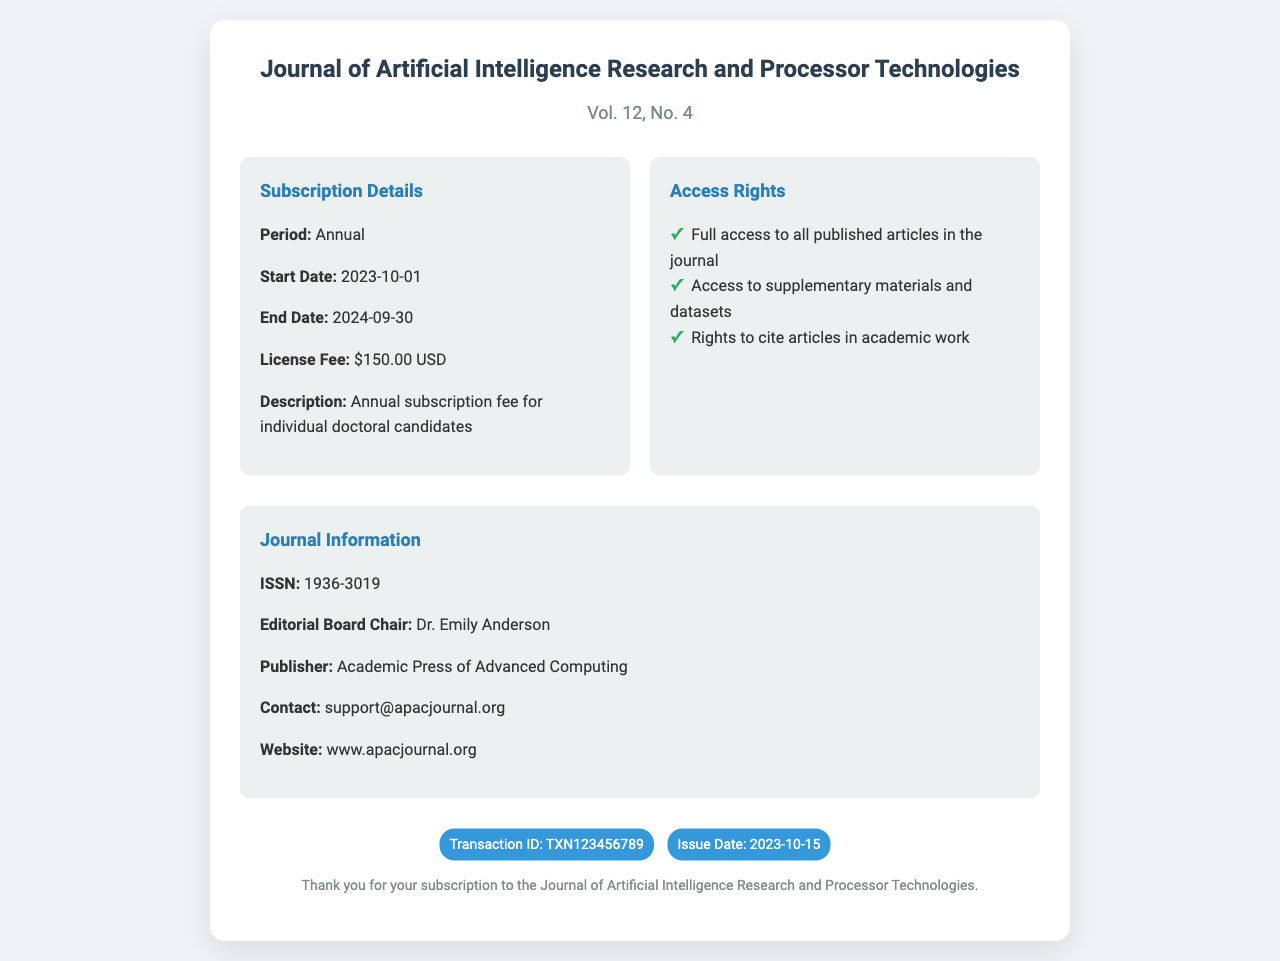what is the journal name? The journal name appears at the top of the document, identifying the publication.
Answer: Journal of Artificial Intelligence Research and Processor Technologies what is the license fee? The license fee is listed in the Subscription Details section of the document.
Answer: $150.00 USD what is the subscription period? The duration of the subscription is specified in the Subscription Details section.
Answer: Annual when does the subscription start? The start date of the subscription is provided under Subscription Details.
Answer: 2023-10-01 what rights do you have concerning the articles? The Access Rights section lists the entitlements granted with the subscription.
Answer: Full access to all published articles in the journal how many access rights are listed? The number of access rights can be counted from the Access Rights section.
Answer: Three who is the Editorial Board Chair? The document specifies the individual holding this position in the Journal Information section.
Answer: Dr. Emily Anderson what is the issue date of this subscription receipt? The issue date is mentioned in the footer of the document.
Answer: 2023-10-15 what is the contact email for the publisher? The contact information is provided in the Journal Information section.
Answer: support@apacjournal.org 